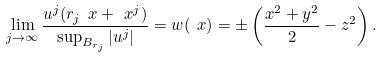<formula> <loc_0><loc_0><loc_500><loc_500>\lim _ { j \to \infty } \frac { u ^ { j } ( r _ { j } \ x + \ x ^ { j } ) } { \sup _ { B _ { r _ { j } } } | u ^ { j } | } = w ( \ x ) = \pm \left ( \frac { x ^ { 2 } + y ^ { 2 } } { 2 } - z ^ { 2 } \right ) .</formula> 